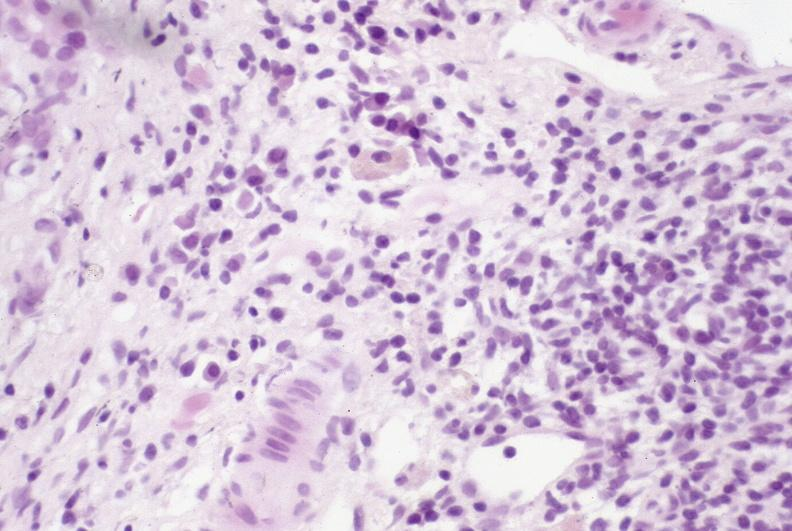s liver present?
Answer the question using a single word or phrase. Yes 